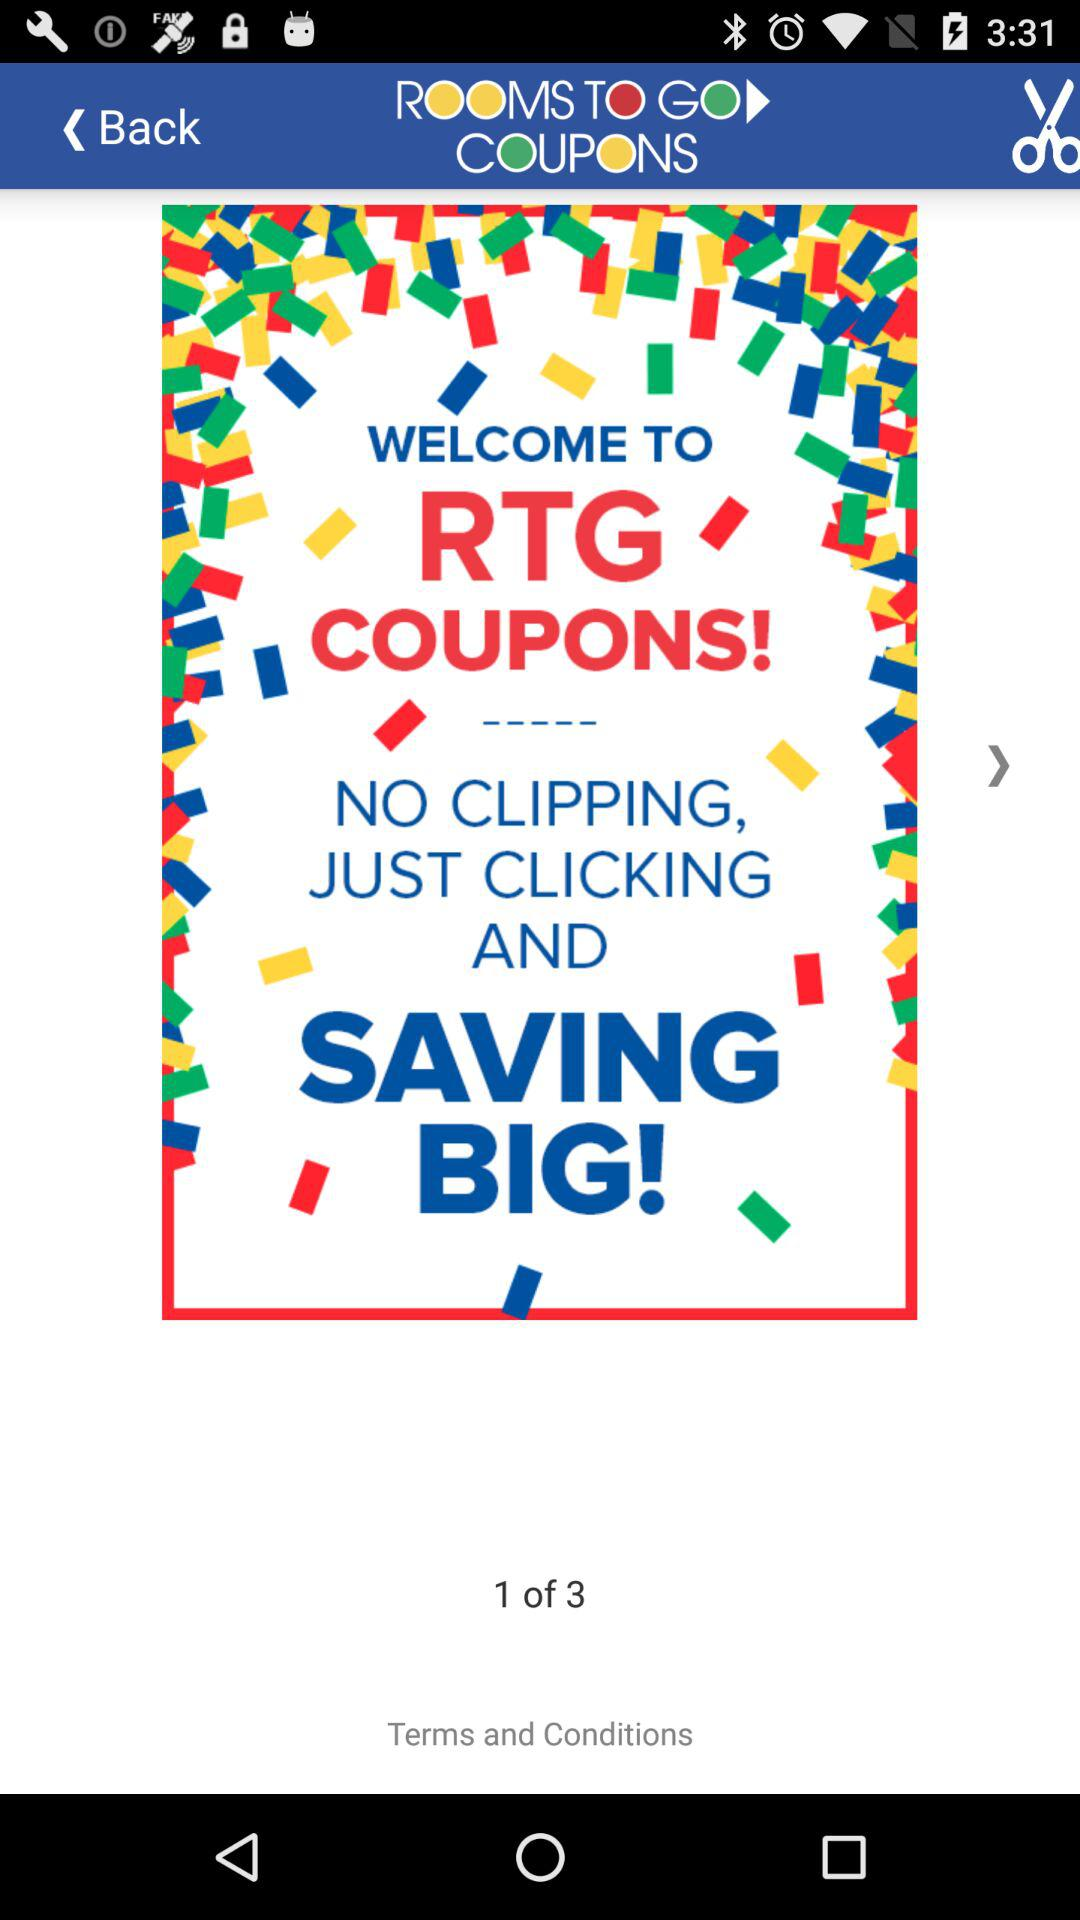How many total rooms are there?
When the provided information is insufficient, respond with <no answer>. <no answer> 